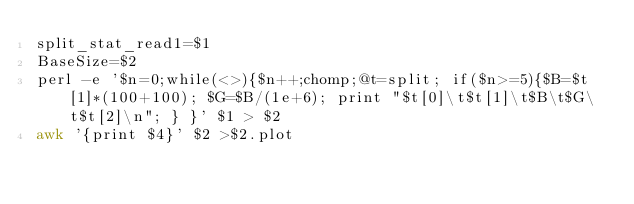Convert code to text. <code><loc_0><loc_0><loc_500><loc_500><_Bash_>split_stat_read1=$1
BaseSize=$2
perl -e '$n=0;while(<>){$n++;chomp;@t=split; if($n>=5){$B=$t[1]*(100+100); $G=$B/(1e+6); print "$t[0]\t$t[1]\t$B\t$G\t$t[2]\n"; } }' $1 > $2
awk '{print $4}' $2 >$2.plot
</code> 